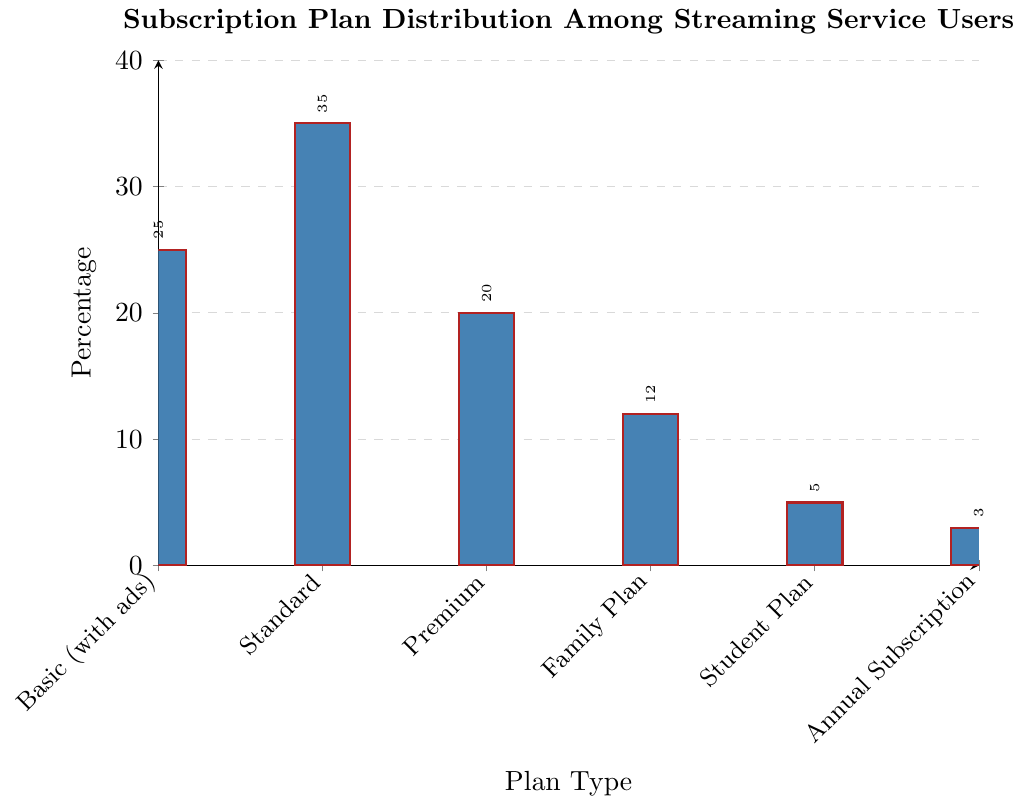What is the most popular subscription plan among users? The bar chart shows different subscription plans and their respective percentages. By comparing the heights of the bars, we see that the Standard plan has the highest percentage.
Answer: Standard Which subscription plan has the smallest percentage of users? The chart displays the distribution and percentages of various plans. The bar for Annual Subscription is the shortest, indicating it has the smallest percentage at 3%.
Answer: Annual Subscription How much higher is the percentage of users on the Standard plan compared to the Premium plan? The bar for the Standard plan is at 35%, and the bar for the Premium plan is at 20%. Subtracting these percentages gives 35% - 20% = 15%.
Answer: 15% What is the combined percentage of users subscribed to the Family Plan, Student Plan, and Annual Subscription? Add the percentages of the Family Plan (12%), Student Plan (5%), and Annual Subscription (3%). The total is 12% + 5% + 3% = 20%.
Answer: 20% Which plans collectively cover more than 50% of the users? Adding the percentages of each plan from highest to lowest: Standard (35%) + Basic with ads (25%) = 60%. This total exceeds 50%. Hence, Standard and Basic (with ads) collectively cover more than 50% of the users.
Answer: Standard, Basic (with ads) What is the average percentage of users across all subscription plans? Sum all percentage values: 25% + 35% + 20% + 12% + 5% + 3% = 100%. There are 6 plans, so the average is 100% / 6 ≈ 16.67%.
Answer: 16.67% Are there more users subscribed to the Basic (with ads) plan or to the combined Family Plan and Student Plan? Basic (with ads) has 25%, and the combined Family Plan and Student Plan have 12% + 5% = 17%. 25% is greater than 17%, so more users are subscribed to Basic (with ads).
Answer: Basic (with ads) How many more percentage points do Standard plan users make up compared to Family Plan users? The Standard plan is at 35% while the Family Plan is at 12%. Subtracting these percentages gives 35% - 12% = 23%.
Answer: 23% Compare the percentages of users on the Premium plan to those on the Family Plan. The Premium plan has 20% of users, and the Family Plan has 12%. Hence, the Premium plan has a higher percentage than the Family Plan.
Answer: Premium 